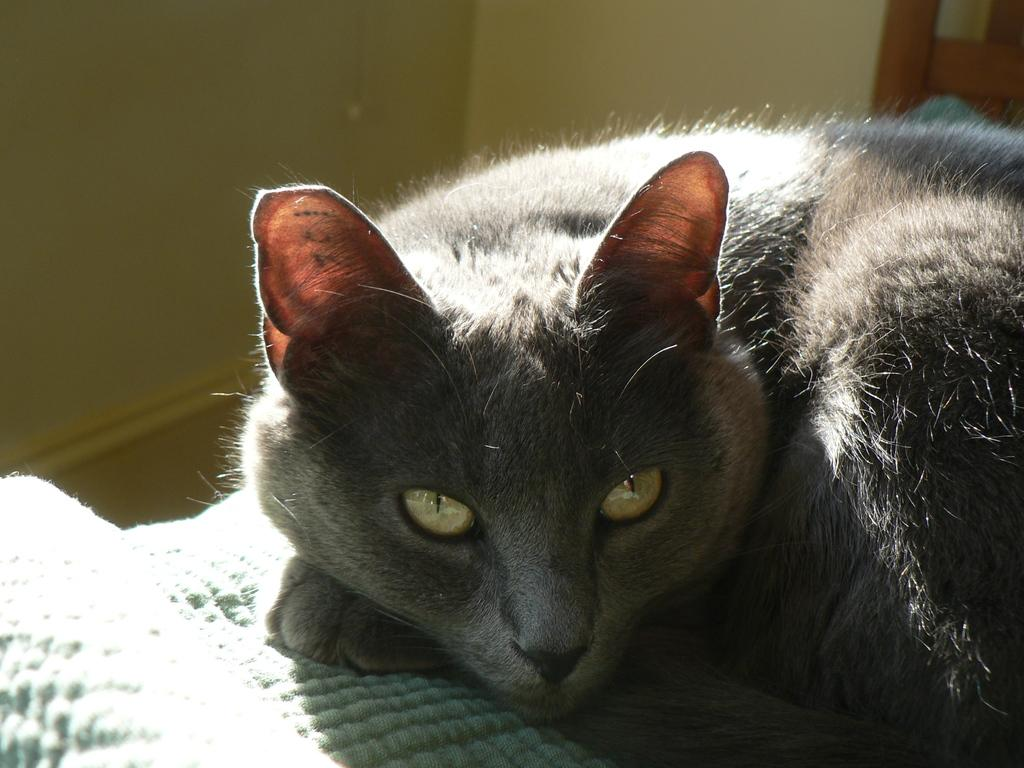What type of animal is in the image? There is a black color cat in the image. What object can be seen in the image besides the cat? There is a cloth in the image. What is the background of the image? There is a wall in the image. What type of fuel is the cat using to power its movements in the image? Cats do not use fuel to power their movements; they rely on their own energy and muscle power. How many chickens are present in the image? There are no chickens present in the image. 